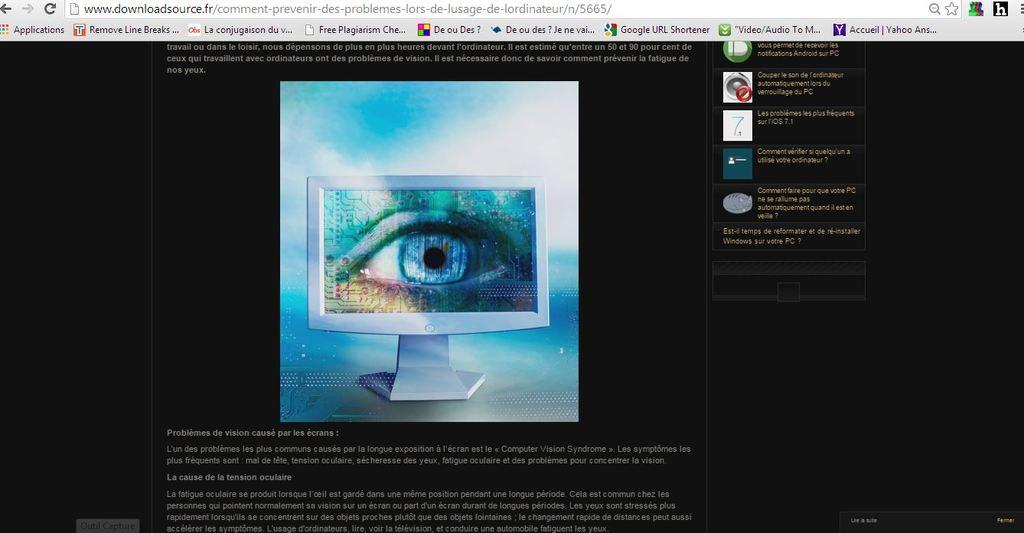<image>
Share a concise interpretation of the image provided. Computer monitor showing a site with tabs for Applications and Remove Line Breaks. 